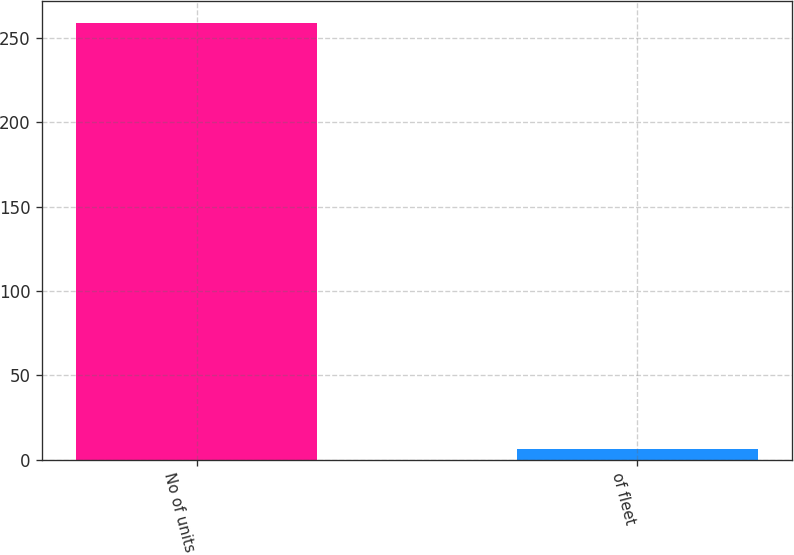<chart> <loc_0><loc_0><loc_500><loc_500><bar_chart><fcel>No of units<fcel>of fleet<nl><fcel>259<fcel>6<nl></chart> 